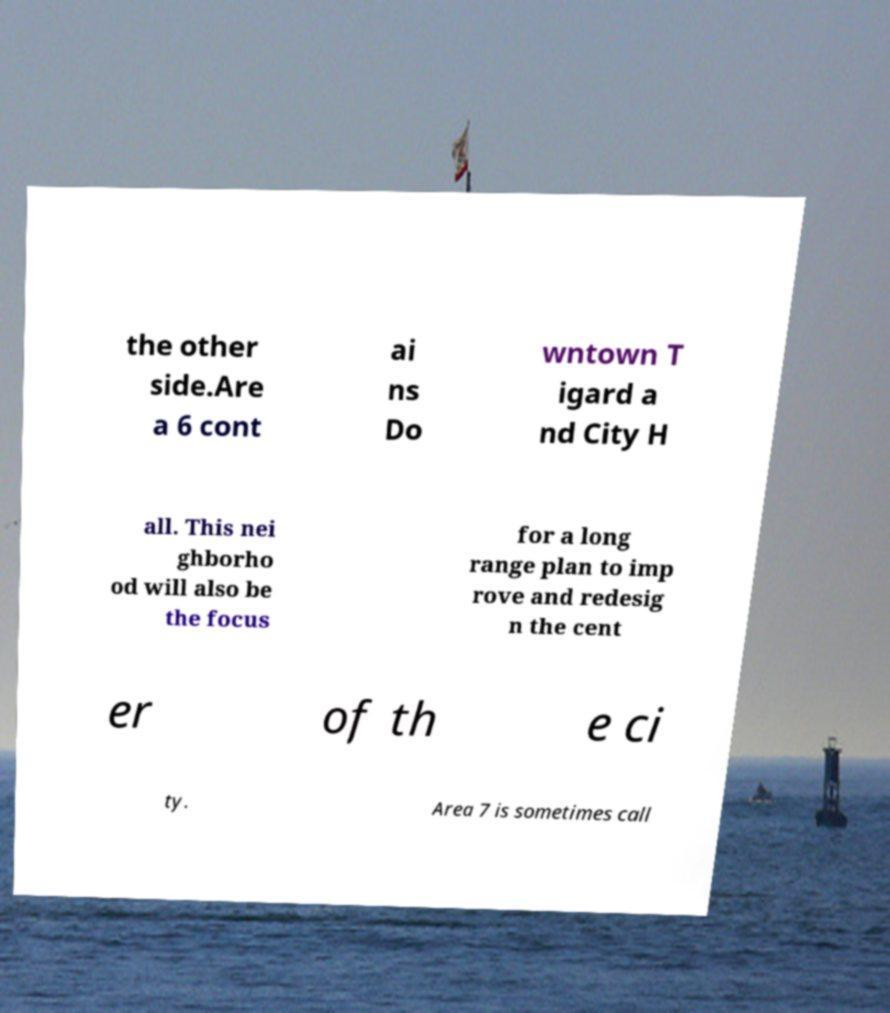Please identify and transcribe the text found in this image. the other side.Are a 6 cont ai ns Do wntown T igard a nd City H all. This nei ghborho od will also be the focus for a long range plan to imp rove and redesig n the cent er of th e ci ty. Area 7 is sometimes call 